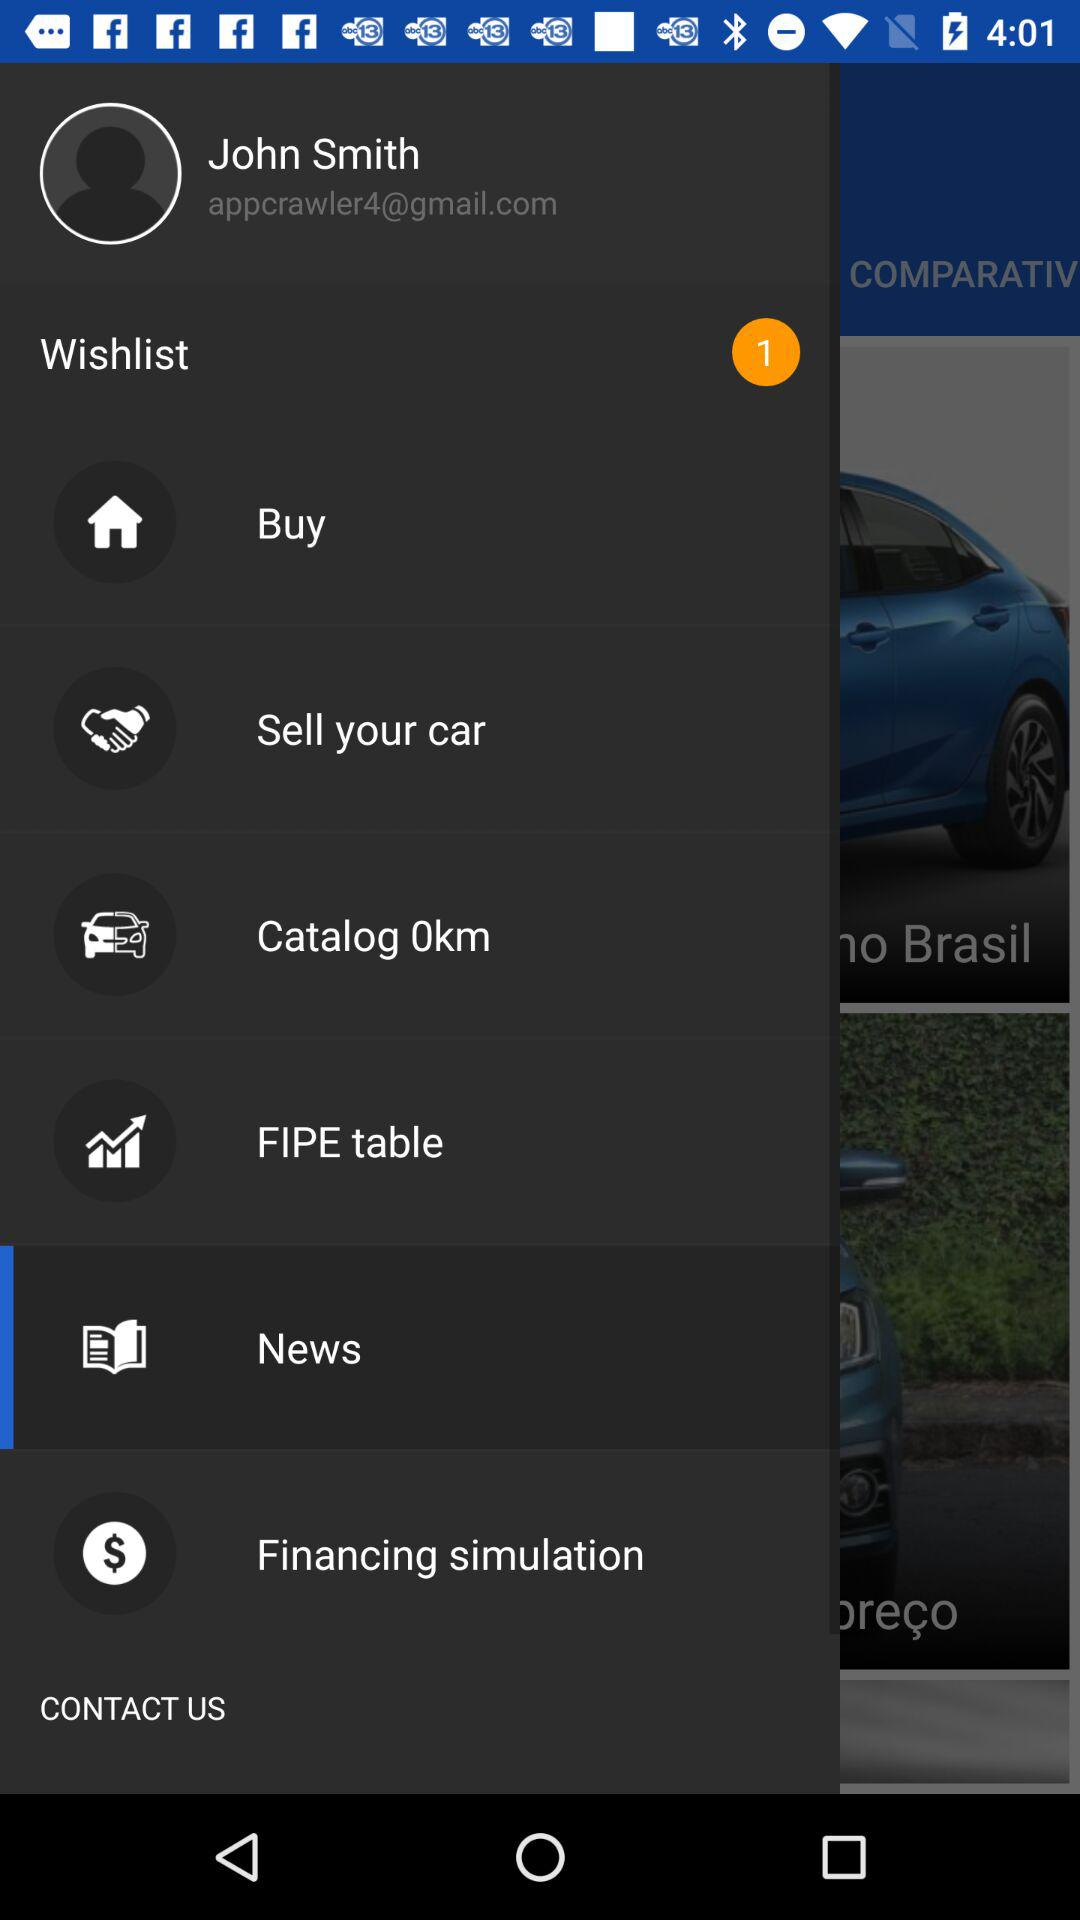What is the email address? The email address is appcrawler4@gmail.com. 